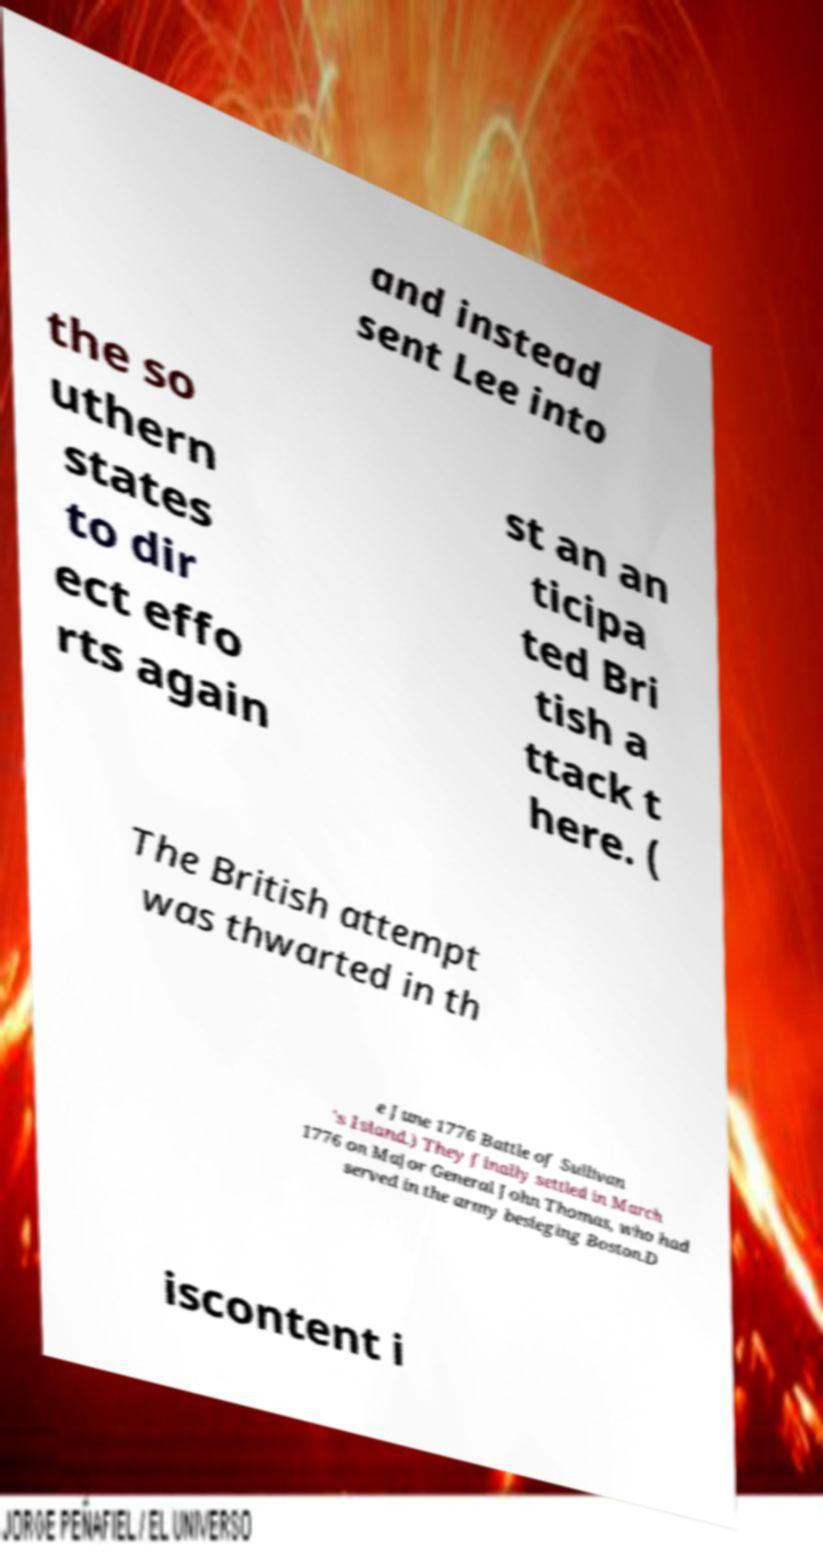There's text embedded in this image that I need extracted. Can you transcribe it verbatim? and instead sent Lee into the so uthern states to dir ect effo rts again st an an ticipa ted Bri tish a ttack t here. ( The British attempt was thwarted in th e June 1776 Battle of Sullivan 's Island.) They finally settled in March 1776 on Major General John Thomas, who had served in the army besieging Boston.D iscontent i 